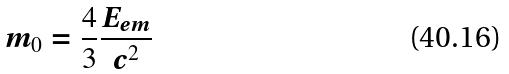<formula> <loc_0><loc_0><loc_500><loc_500>m _ { 0 } = \frac { 4 } { 3 } \frac { E _ { e m } } { c ^ { 2 } }</formula> 